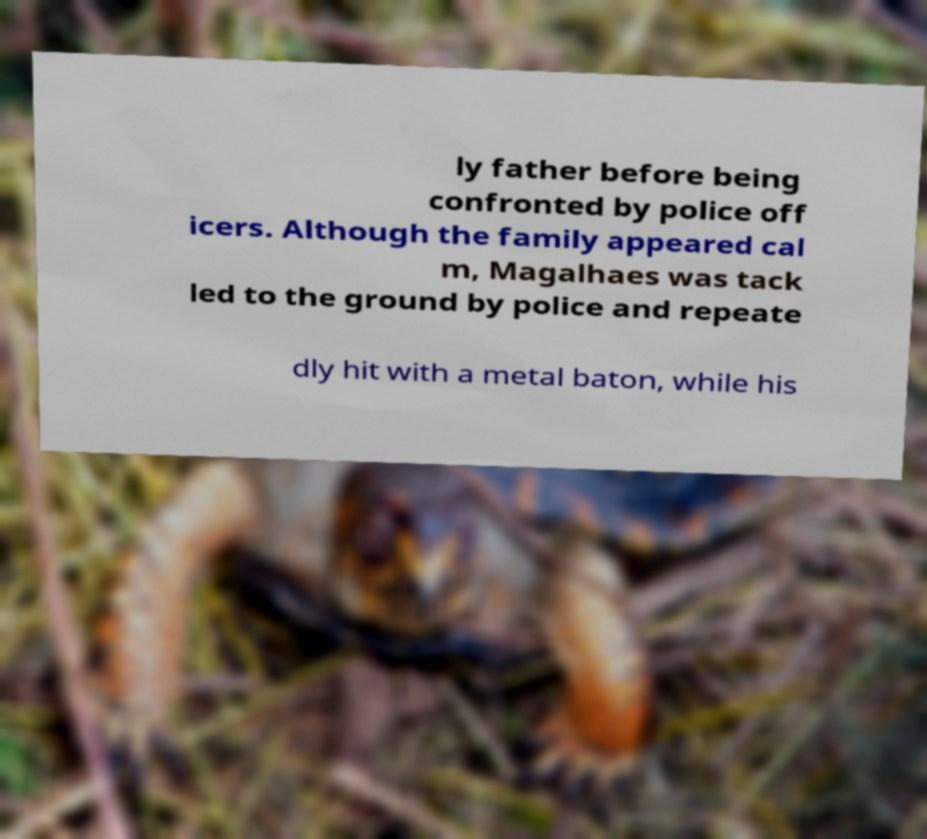Please identify and transcribe the text found in this image. ly father before being confronted by police off icers. Although the family appeared cal m, Magalhaes was tack led to the ground by police and repeate dly hit with a metal baton, while his 